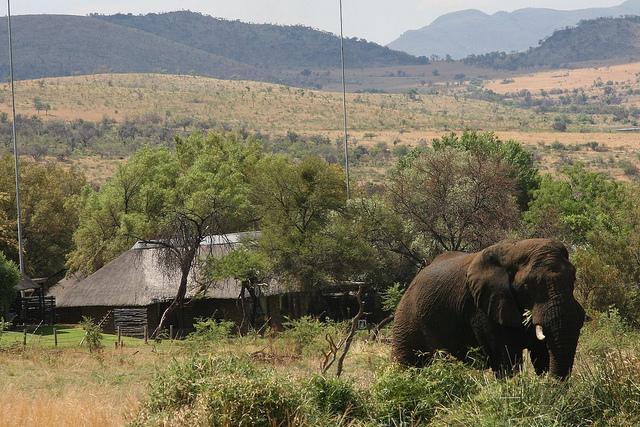How many elephants are in the photo?
Give a very brief answer. 1. 